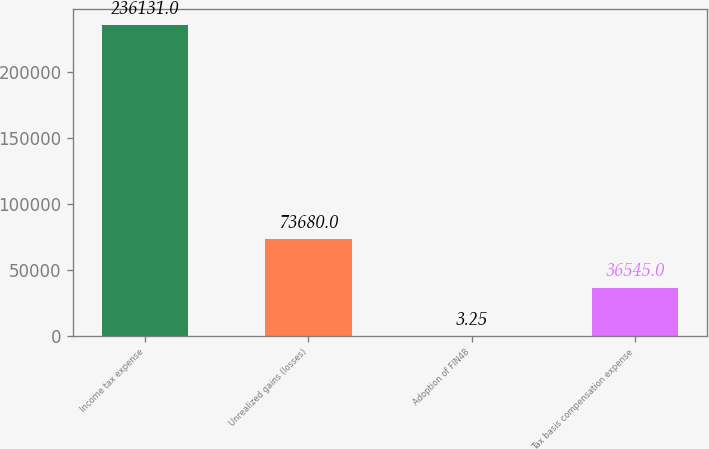Convert chart. <chart><loc_0><loc_0><loc_500><loc_500><bar_chart><fcel>Income tax expense<fcel>Unrealized gains (losses)<fcel>Adoption of FIN48<fcel>Tax basis compensation expense<nl><fcel>236131<fcel>73680<fcel>3.25<fcel>36545<nl></chart> 